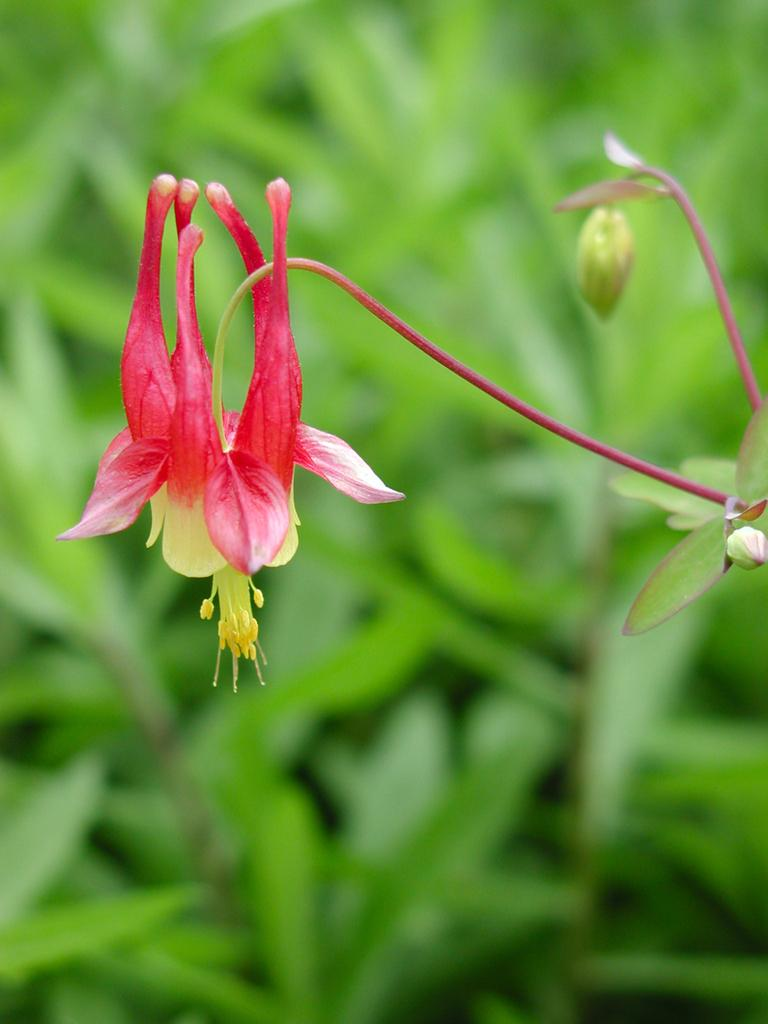What type of plant is depicted in the image? There is a flower in the image. What parts of the plant are visible in the image? There are stems and buds visible in the image. What colors can be seen in the background of the image? The background of the image is blue and green. What type of light source is illuminating the flower in the image? There is no specific light source mentioned or visible in the image, as it features a flower and plant parts against a blue and green background. 